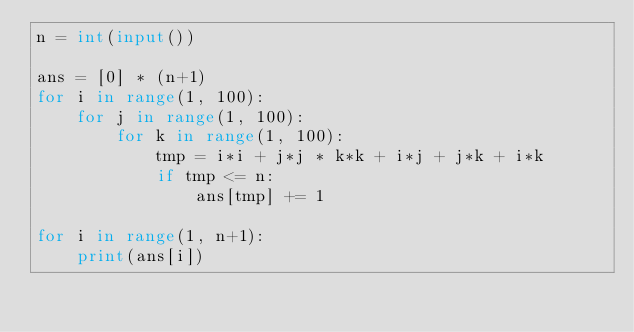Convert code to text. <code><loc_0><loc_0><loc_500><loc_500><_Python_>n = int(input())

ans = [0] * (n+1)
for i in range(1, 100):
    for j in range(1, 100):
        for k in range(1, 100):
            tmp = i*i + j*j * k*k + i*j + j*k + i*k
            if tmp <= n:
                ans[tmp] += 1

for i in range(1, n+1):
    print(ans[i])
</code> 